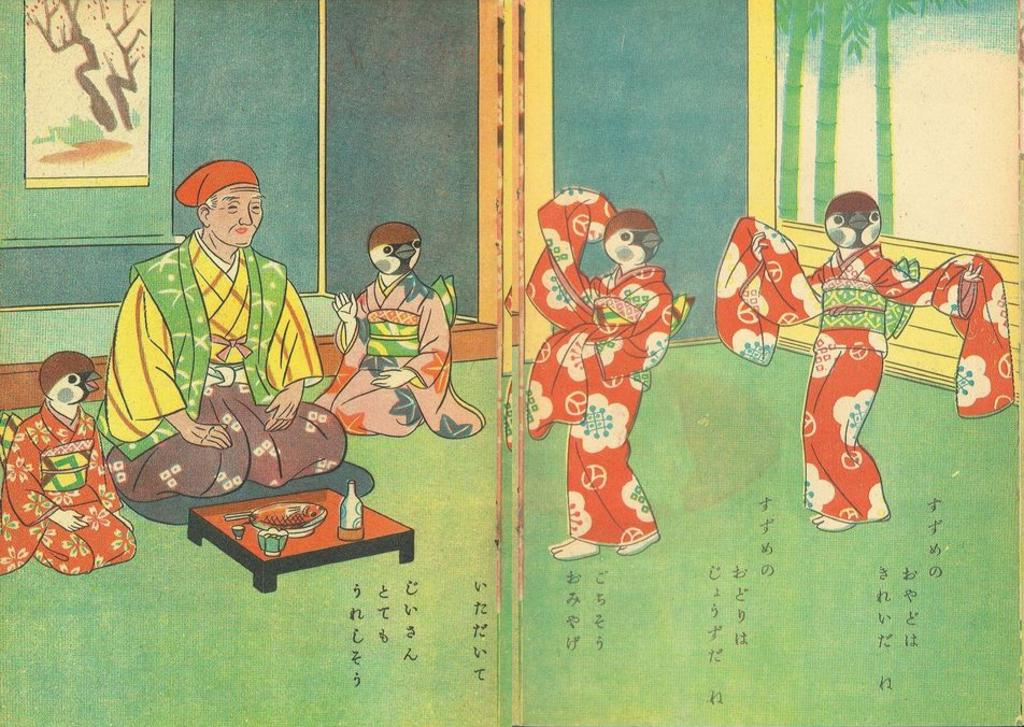What is the man in the image doing? The man is sitting in the image. What objects are on the table in the image? There is a glass, a plate, and a bowl on the table in the image. What type of owl can be seen sitting on the man's shoulder in the image? There is no owl present in the image; the man is sitting alone. 